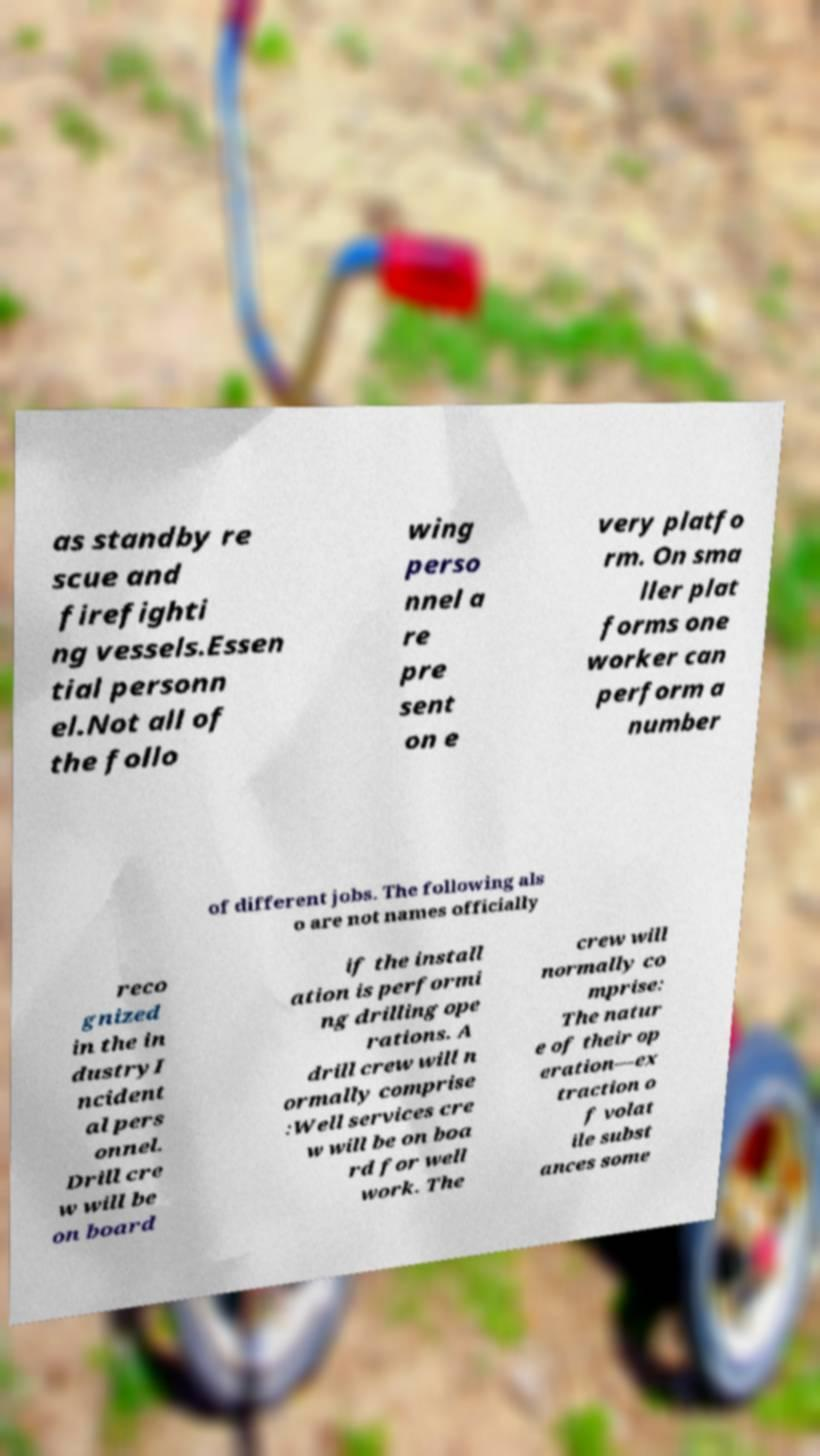Could you extract and type out the text from this image? as standby re scue and firefighti ng vessels.Essen tial personn el.Not all of the follo wing perso nnel a re pre sent on e very platfo rm. On sma ller plat forms one worker can perform a number of different jobs. The following als o are not names officially reco gnized in the in dustryI ncident al pers onnel. Drill cre w will be on board if the install ation is performi ng drilling ope rations. A drill crew will n ormally comprise :Well services cre w will be on boa rd for well work. The crew will normally co mprise: The natur e of their op eration—ex traction o f volat ile subst ances some 